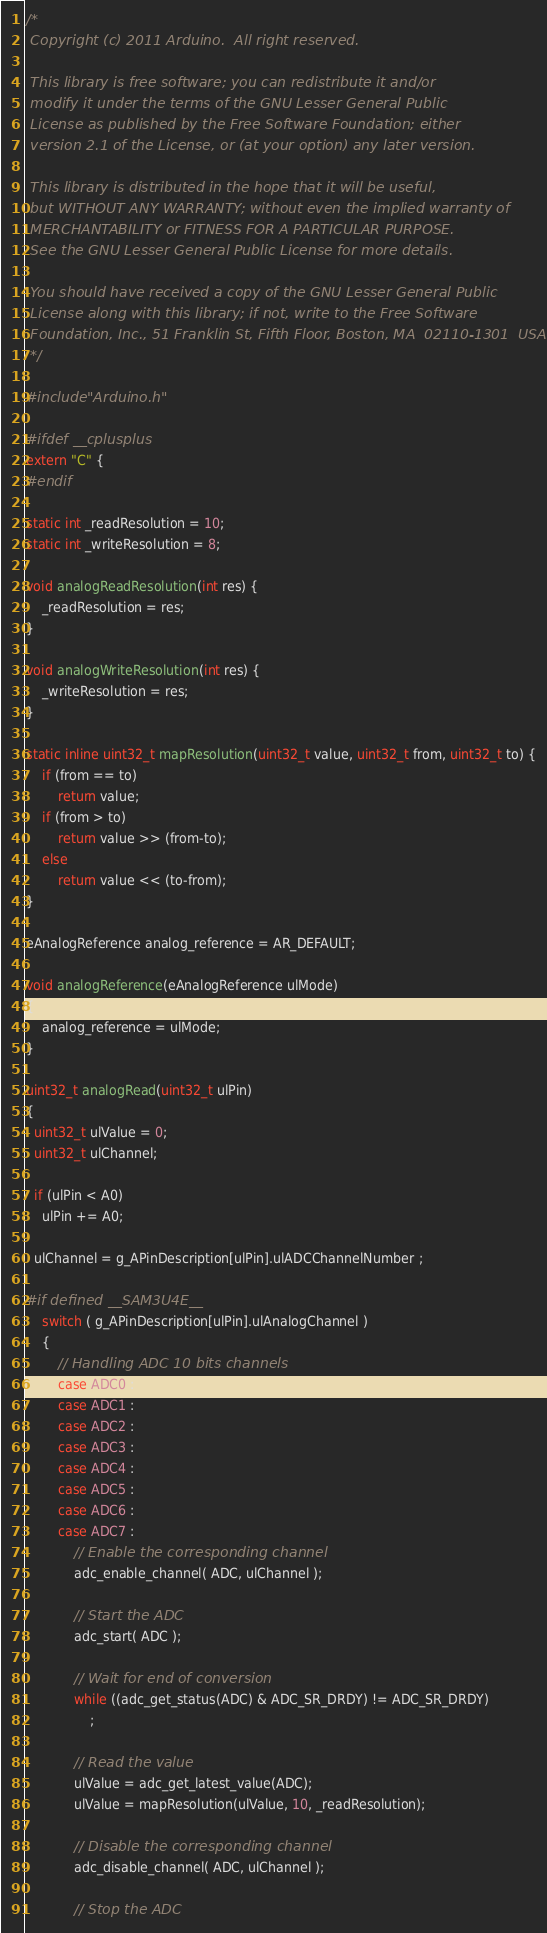<code> <loc_0><loc_0><loc_500><loc_500><_C_>/*
 Copyright (c) 2011 Arduino.  All right reserved.

 This library is free software; you can redistribute it and/or
 modify it under the terms of the GNU Lesser General Public
 License as published by the Free Software Foundation; either
 version 2.1 of the License, or (at your option) any later version.

 This library is distributed in the hope that it will be useful,
 but WITHOUT ANY WARRANTY; without even the implied warranty of
 MERCHANTABILITY or FITNESS FOR A PARTICULAR PURPOSE.
 See the GNU Lesser General Public License for more details.

 You should have received a copy of the GNU Lesser General Public
 License along with this library; if not, write to the Free Software
 Foundation, Inc., 51 Franklin St, Fifth Floor, Boston, MA  02110-1301  USA
 */

#include "Arduino.h"

#ifdef __cplusplus
extern "C" {
#endif

static int _readResolution = 10;
static int _writeResolution = 8;

void analogReadResolution(int res) {
	_readResolution = res;
}

void analogWriteResolution(int res) {
	_writeResolution = res;
}

static inline uint32_t mapResolution(uint32_t value, uint32_t from, uint32_t to) {
	if (from == to)
		return value;
	if (from > to)
		return value >> (from-to);
	else
		return value << (to-from);
}

eAnalogReference analog_reference = AR_DEFAULT;

void analogReference(eAnalogReference ulMode)
{
	analog_reference = ulMode;
}

uint32_t analogRead(uint32_t ulPin)
{
  uint32_t ulValue = 0;
  uint32_t ulChannel;

  if (ulPin < A0)
    ulPin += A0;

  ulChannel = g_APinDescription[ulPin].ulADCChannelNumber ;

#if defined __SAM3U4E__
	switch ( g_APinDescription[ulPin].ulAnalogChannel )
	{
		// Handling ADC 10 bits channels
		case ADC0 :
		case ADC1 :
		case ADC2 :
		case ADC3 :
		case ADC4 :
		case ADC5 :
		case ADC6 :
		case ADC7 :
			// Enable the corresponding channel
			adc_enable_channel( ADC, ulChannel );

			// Start the ADC
			adc_start( ADC );

			// Wait for end of conversion
			while ((adc_get_status(ADC) & ADC_SR_DRDY) != ADC_SR_DRDY)
				;

			// Read the value
			ulValue = adc_get_latest_value(ADC);
			ulValue = mapResolution(ulValue, 10, _readResolution);

			// Disable the corresponding channel
			adc_disable_channel( ADC, ulChannel );

			// Stop the ADC</code> 